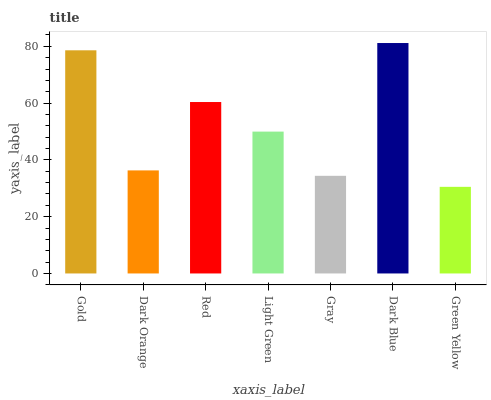Is Green Yellow the minimum?
Answer yes or no. Yes. Is Dark Blue the maximum?
Answer yes or no. Yes. Is Dark Orange the minimum?
Answer yes or no. No. Is Dark Orange the maximum?
Answer yes or no. No. Is Gold greater than Dark Orange?
Answer yes or no. Yes. Is Dark Orange less than Gold?
Answer yes or no. Yes. Is Dark Orange greater than Gold?
Answer yes or no. No. Is Gold less than Dark Orange?
Answer yes or no. No. Is Light Green the high median?
Answer yes or no. Yes. Is Light Green the low median?
Answer yes or no. Yes. Is Dark Orange the high median?
Answer yes or no. No. Is Dark Blue the low median?
Answer yes or no. No. 